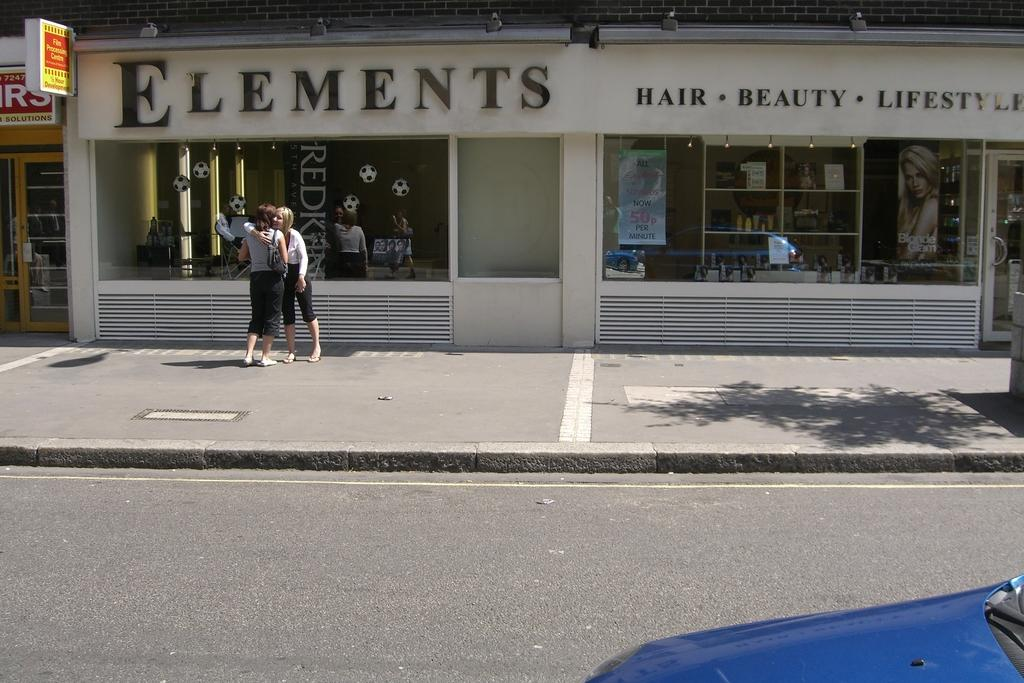<image>
Create a compact narrative representing the image presented. Two women hug in front a storefront for Elements. 